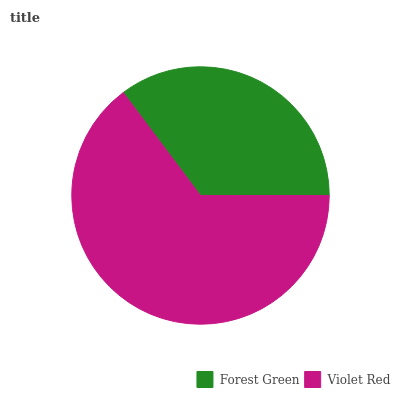Is Forest Green the minimum?
Answer yes or no. Yes. Is Violet Red the maximum?
Answer yes or no. Yes. Is Violet Red the minimum?
Answer yes or no. No. Is Violet Red greater than Forest Green?
Answer yes or no. Yes. Is Forest Green less than Violet Red?
Answer yes or no. Yes. Is Forest Green greater than Violet Red?
Answer yes or no. No. Is Violet Red less than Forest Green?
Answer yes or no. No. Is Violet Red the high median?
Answer yes or no. Yes. Is Forest Green the low median?
Answer yes or no. Yes. Is Forest Green the high median?
Answer yes or no. No. Is Violet Red the low median?
Answer yes or no. No. 